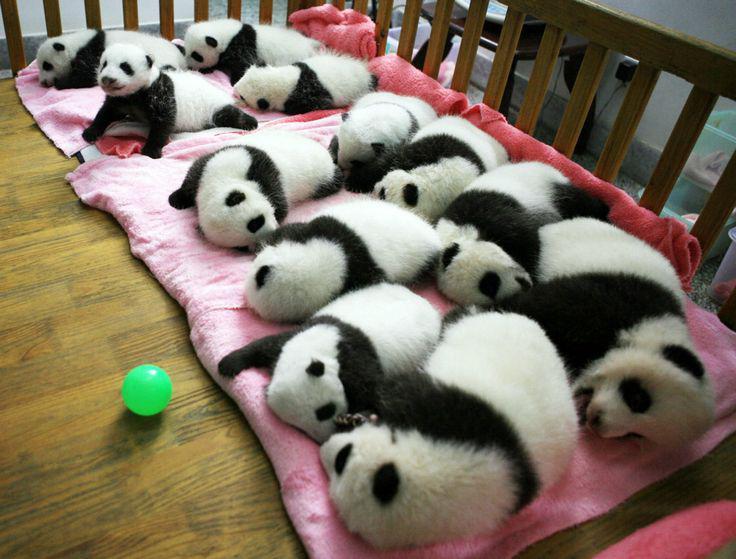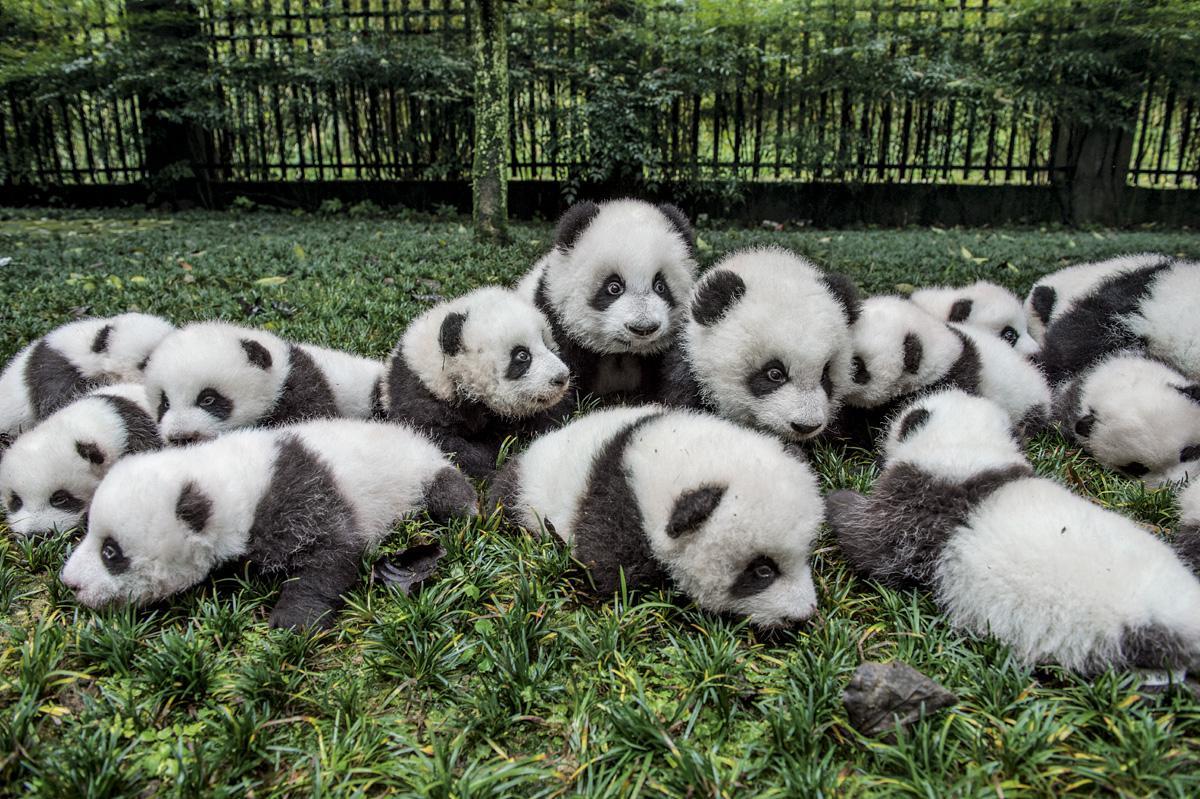The first image is the image on the left, the second image is the image on the right. Assess this claim about the two images: "An image shows rows of pandas sleeping on a pink blanket surrounded by rails, and a green ball is next to the blanket.". Correct or not? Answer yes or no. Yes. The first image is the image on the left, the second image is the image on the right. Given the left and right images, does the statement "The left image contains baby pandas sleeping on a pink blanket." hold true? Answer yes or no. Yes. 